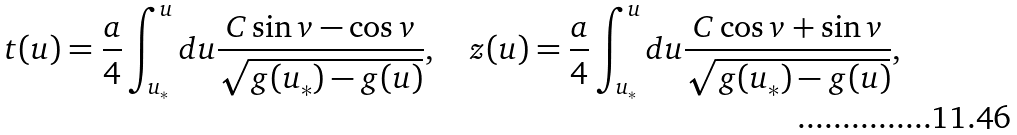Convert formula to latex. <formula><loc_0><loc_0><loc_500><loc_500>t ( u ) = \frac { a } { 4 } \int _ { u _ { * } } ^ { u } d u \frac { C \sin v - \cos v } { \sqrt { g ( u _ { * } ) - g ( u ) } } , \quad z ( u ) = \frac { a } { 4 } \int _ { u _ { * } } ^ { u } d u \frac { C \cos v + \sin v } { \sqrt { g ( u _ { * } ) - g ( u ) } } ,</formula> 